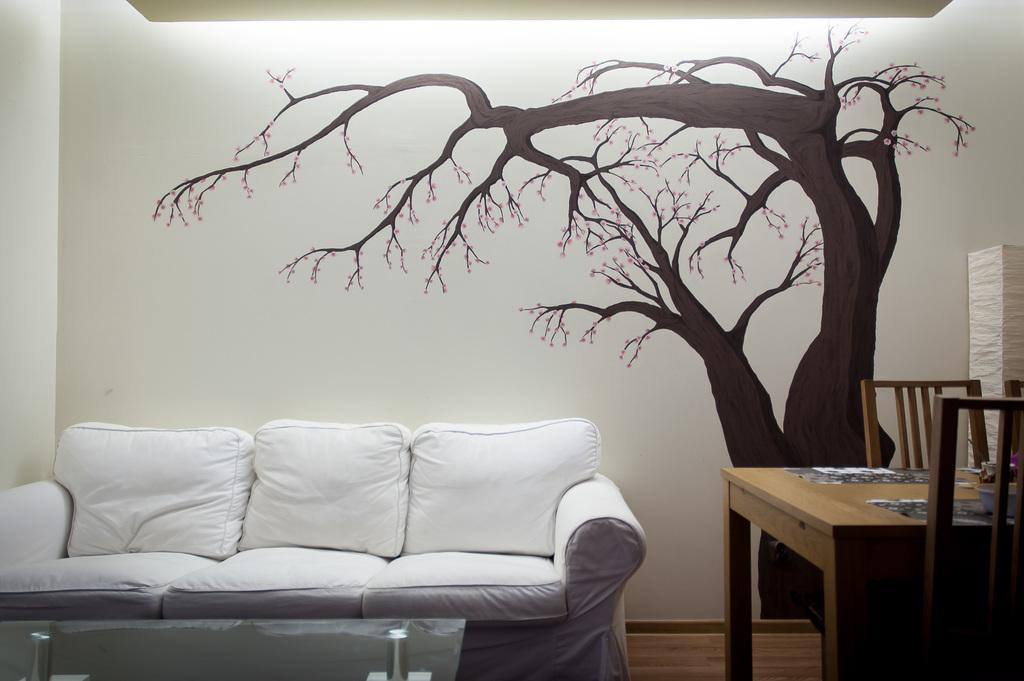What type of furniture is present in the image? There is a sofa, a table, and two chairs in the image. What is depicted on the wall in the image? There is a tree painting on the wall in the image. Can you see a river flowing through the room in the image? There is no river visible in the image; it features indoor furniture and a tree painting on the wall. What type of cannon is present in the image? There is no cannon present in the image. 